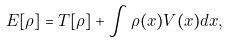<formula> <loc_0><loc_0><loc_500><loc_500>E [ \rho ] = T [ \rho ] + \int \rho ( x ) V ( x ) d x ,</formula> 